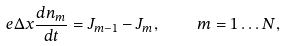<formula> <loc_0><loc_0><loc_500><loc_500>e \Delta x \frac { d n _ { m } } { d t } = J _ { m - 1 } - J _ { m } , \quad m = 1 \dots N ,</formula> 